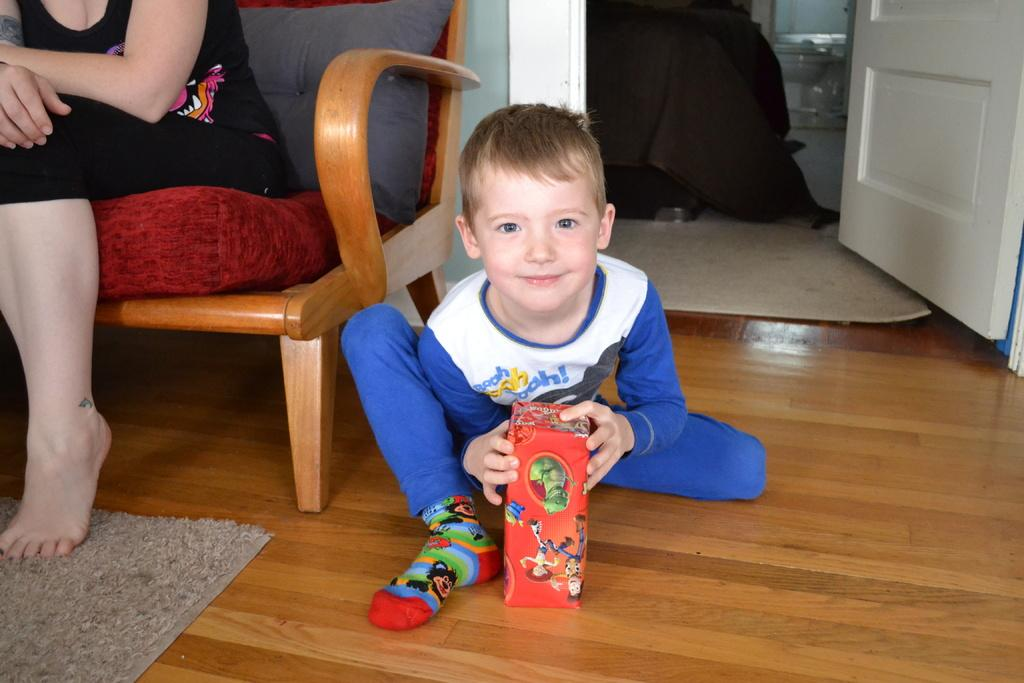What is the boy in the image doing? The boy is seated on the floor in the image. What is the boy holding in his hand? The boy is holding a box in his hand. Who else is present in the image? There is a woman seated on a chair in the image. What can be seen in the background of the image? There is a door visible in the image. What type of flooring is present in the image? There is a carpet and a floor mat in the image. What is the title of the book the boy is reading in the image? There is no book present in the image, so there is no title to reference. How does the drain in the image affect the cream on the floor? There is no drain or cream present in the image, so this question cannot be answered. 